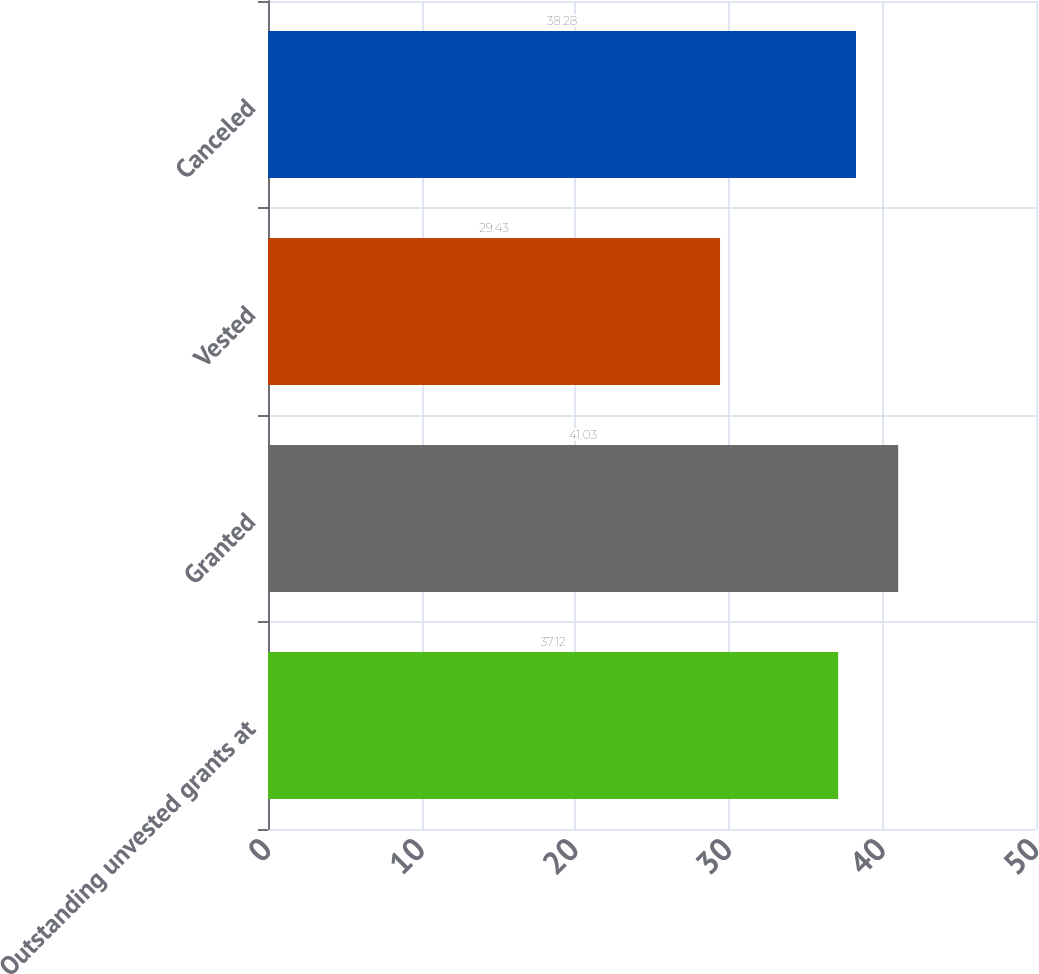<chart> <loc_0><loc_0><loc_500><loc_500><bar_chart><fcel>Outstanding unvested grants at<fcel>Granted<fcel>Vested<fcel>Canceled<nl><fcel>37.12<fcel>41.03<fcel>29.43<fcel>38.28<nl></chart> 